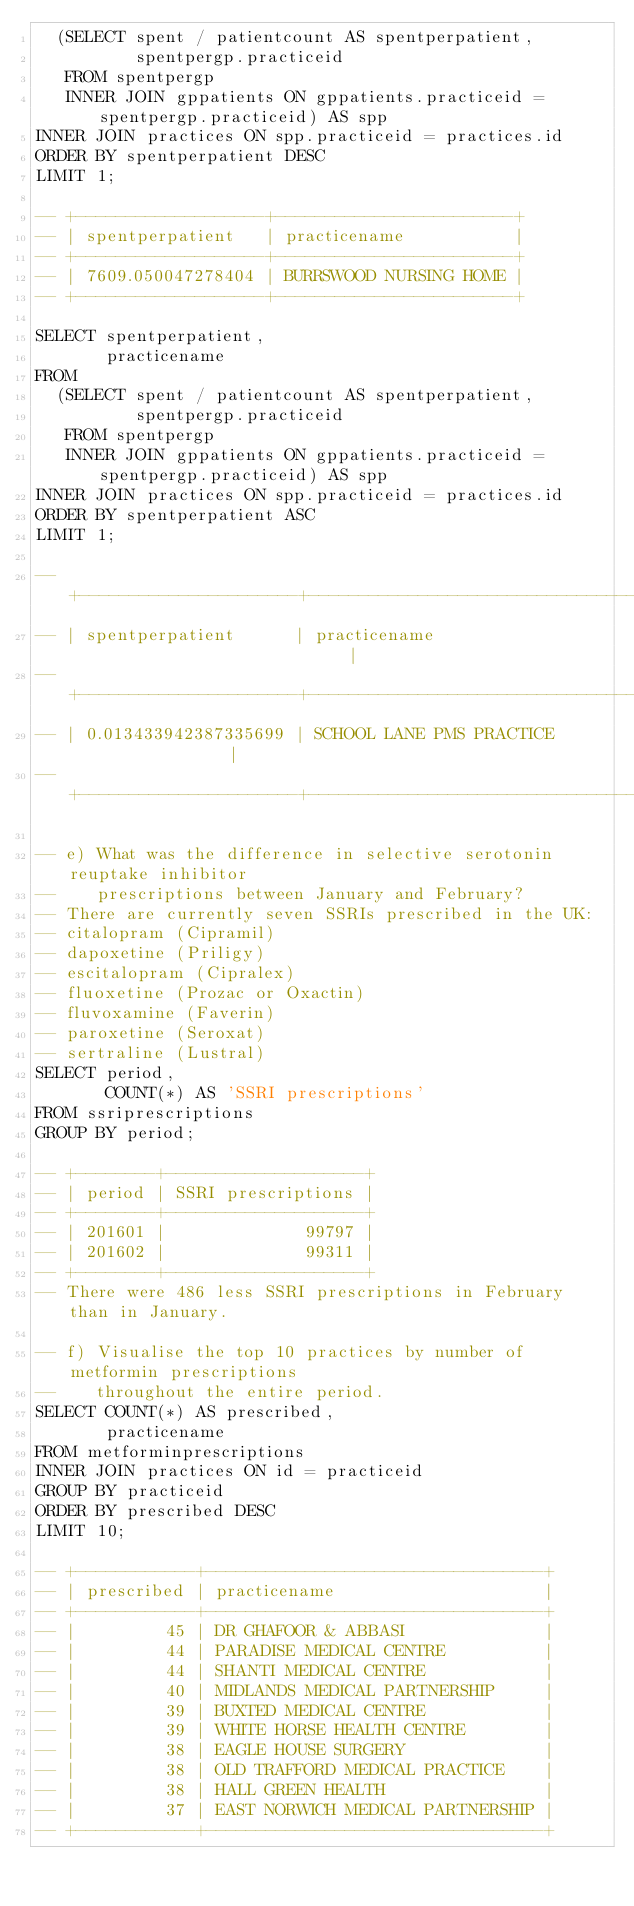Convert code to text. <code><loc_0><loc_0><loc_500><loc_500><_SQL_>  (SELECT spent / patientcount AS spentperpatient,
          spentpergp.practiceid
   FROM spentpergp
   INNER JOIN gppatients ON gppatients.practiceid = spentpergp.practiceid) AS spp
INNER JOIN practices ON spp.practiceid = practices.id
ORDER BY spentperpatient DESC
LIMIT 1;

-- +-------------------+------------------------+
-- | spentperpatient   | practicename           |
-- +-------------------+------------------------+
-- | 7609.050047278404 | BURRSWOOD NURSING HOME |
-- +-------------------+------------------------+

SELECT spentperpatient,
       practicename
FROM
  (SELECT spent / patientcount AS spentperpatient,
          spentpergp.practiceid
   FROM spentpergp
   INNER JOIN gppatients ON gppatients.practiceid = spentpergp.practiceid) AS spp
INNER JOIN practices ON spp.practiceid = practices.id
ORDER BY spentperpatient ASC
LIMIT 1;

-- +----------------------+------------------------------------------+
-- | spentperpatient      | practicename                             |
-- +----------------------+------------------------------------------+
-- | 0.013433942387335699 | SCHOOL LANE PMS PRACTICE                 |
-- +----------------------+------------------------------------------+

-- e) What was the difference in selective serotonin reuptake inhibitor
--    prescriptions between January and February?
-- There are currently seven SSRIs prescribed in the UK:
-- citalopram (Cipramil)
-- dapoxetine (Priligy)
-- escitalopram (Cipralex)
-- fluoxetine (Prozac or Oxactin)
-- fluvoxamine (Faverin)
-- paroxetine (Seroxat)
-- sertraline (Lustral)
SELECT period,
       COUNT(*) AS 'SSRI prescriptions'
FROM ssriprescriptions
GROUP BY period;

-- +--------+--------------------+
-- | period | SSRI prescriptions |
-- +--------+--------------------+
-- | 201601 |              99797 |
-- | 201602 |              99311 |
-- +--------+--------------------+
-- There were 486 less SSRI prescriptions in February than in January.

-- f) Visualise the top 10 practices by number of metformin prescriptions
--    throughout the entire period.
SELECT COUNT(*) AS prescribed,
       practicename
FROM metforminprescriptions
INNER JOIN practices ON id = practiceid
GROUP BY practiceid
ORDER BY prescribed DESC
LIMIT 10;

-- +------------+----------------------------------+
-- | prescribed | practicename                     |
-- +------------+----------------------------------+
-- |         45 | DR GHAFOOR & ABBASI              |
-- |         44 | PARADISE MEDICAL CENTRE          |
-- |         44 | SHANTI MEDICAL CENTRE            |
-- |         40 | MIDLANDS MEDICAL PARTNERSHIP     |
-- |         39 | BUXTED MEDICAL CENTRE            |
-- |         39 | WHITE HORSE HEALTH CENTRE        |
-- |         38 | EAGLE HOUSE SURGERY              |
-- |         38 | OLD TRAFFORD MEDICAL PRACTICE    |
-- |         38 | HALL GREEN HEALTH                |
-- |         37 | EAST NORWICH MEDICAL PARTNERSHIP |
-- +------------+----------------------------------+
</code> 